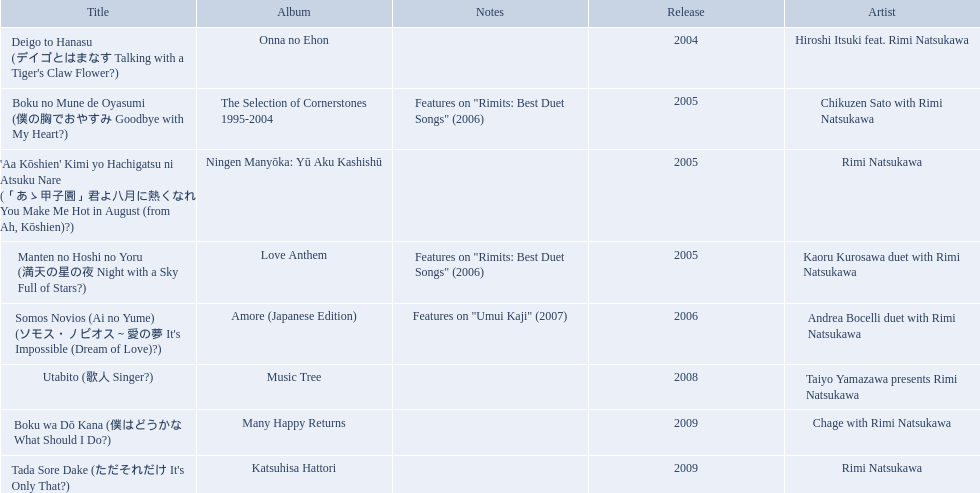What year was onna no ehon released? 2004. What year was music tree released? 2008. Which of the two was not released in 2004? Music Tree. What are the notes for sky full of stars? Features on "Rimits: Best Duet Songs" (2006). What other song features this same note? Boku no Mune de Oyasumi (僕の胸でおやすみ Goodbye with My Heart?). 